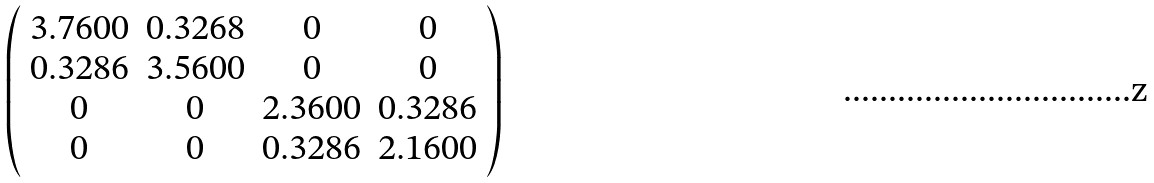<formula> <loc_0><loc_0><loc_500><loc_500>\left ( \begin{array} { c c c c } 3 . 7 6 0 0 & 0 . 3 2 6 8 & 0 & 0 \\ 0 . 3 2 8 6 & 3 . 5 6 0 0 & 0 & 0 \\ 0 & 0 & 2 . 3 6 0 0 & 0 . 3 2 8 6 \\ 0 & 0 & 0 . 3 2 8 6 & 2 . 1 6 0 0 \\ \end{array} \right )</formula> 